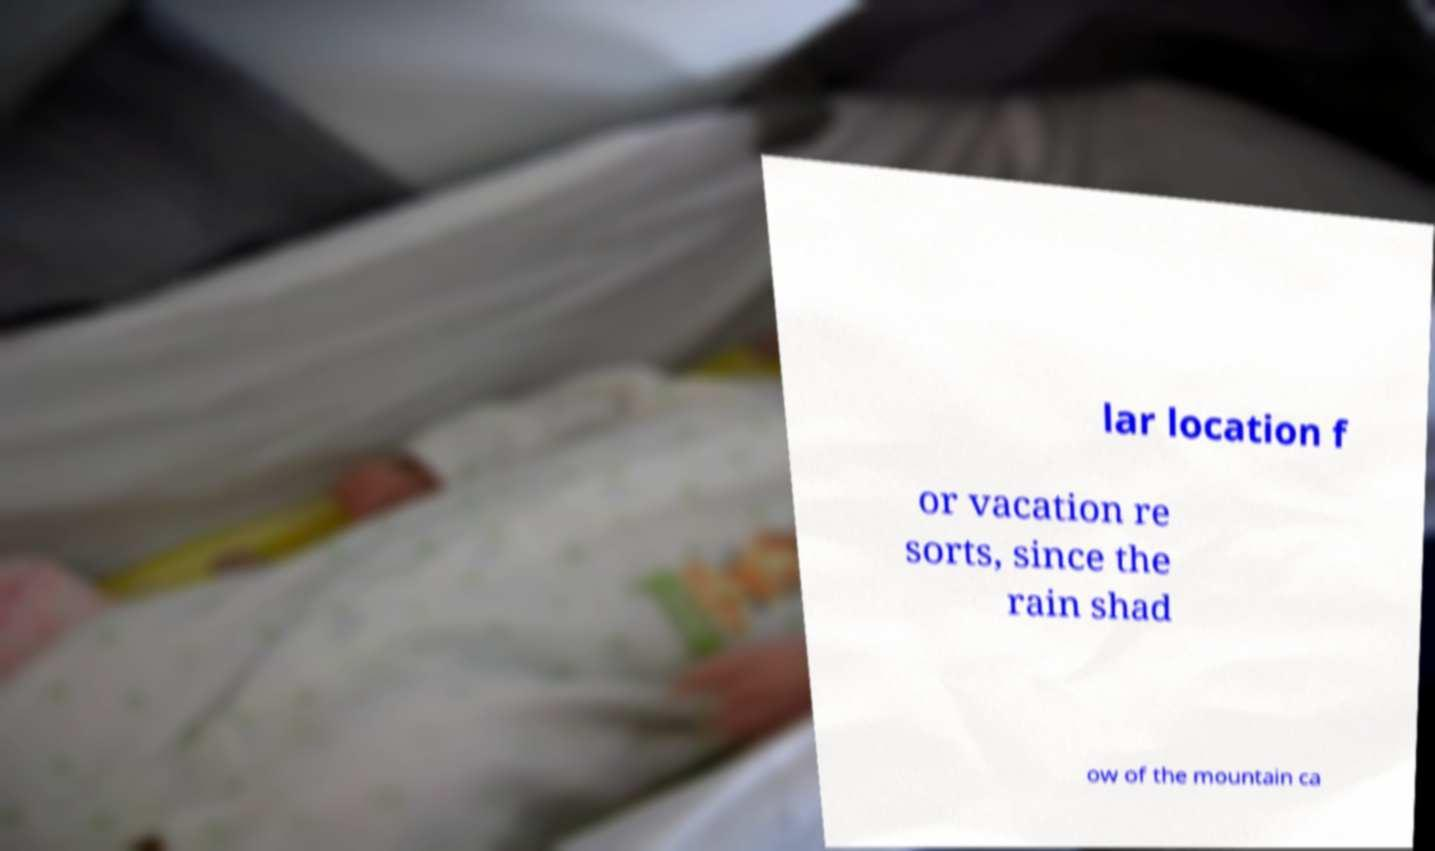Can you accurately transcribe the text from the provided image for me? lar location f or vacation re sorts, since the rain shad ow of the mountain ca 